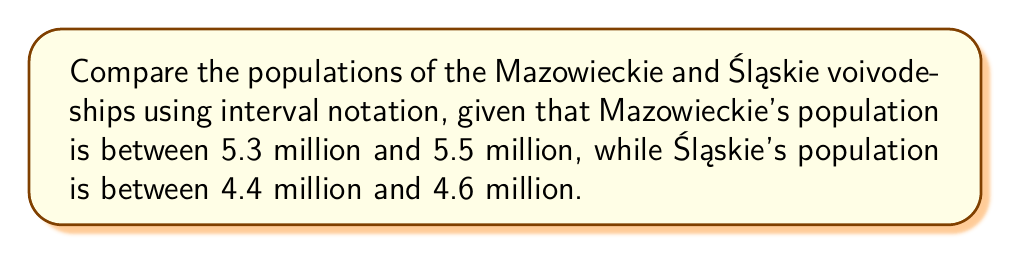Could you help me with this problem? Let's approach this step-by-step:

1. Define the intervals for each voivodeship:
   Mazowieckie: $[5.3, 5.5]$ million
   Śląskie: $[4.4, 4.6]$ million

2. To compare these intervals, we need to look at their endpoints:
   $5.3 > 4.6$ and $5.5 > 4.4$

3. Since the lowest value of Mazowieckie (5.3) is greater than the highest value of Śląskie (4.6), we can conclude that Mazowieckie's population is always greater than Śląskie's.

4. In interval notation, we represent this relationship as:
   $$\text{Mazowieckie} - \text{Śląskie} \in (0.7, 1.1)$$

5. This is because:
   Minimum difference: $5.3 - 4.6 = 0.7$ million
   Maximum difference: $5.5 - 4.4 = 1.1$ million

6. We use open parentheses $($ and $)$ because the exact endpoints are not included in the possible differences.
Answer: $\text{Mazowieckie} - \text{Śląskie} \in (0.7, 1.1)$ 